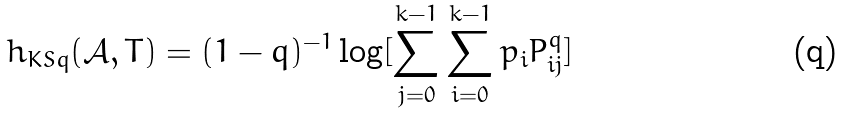Convert formula to latex. <formula><loc_0><loc_0><loc_500><loc_500>h _ { K S q } ( \mathcal { A } , T ) = ( 1 - q ) ^ { - 1 } \log [ \sum _ { j = 0 } ^ { k - 1 } \sum _ { i = 0 } ^ { k - 1 } p _ { i } P _ { i j } ^ { q } ]</formula> 